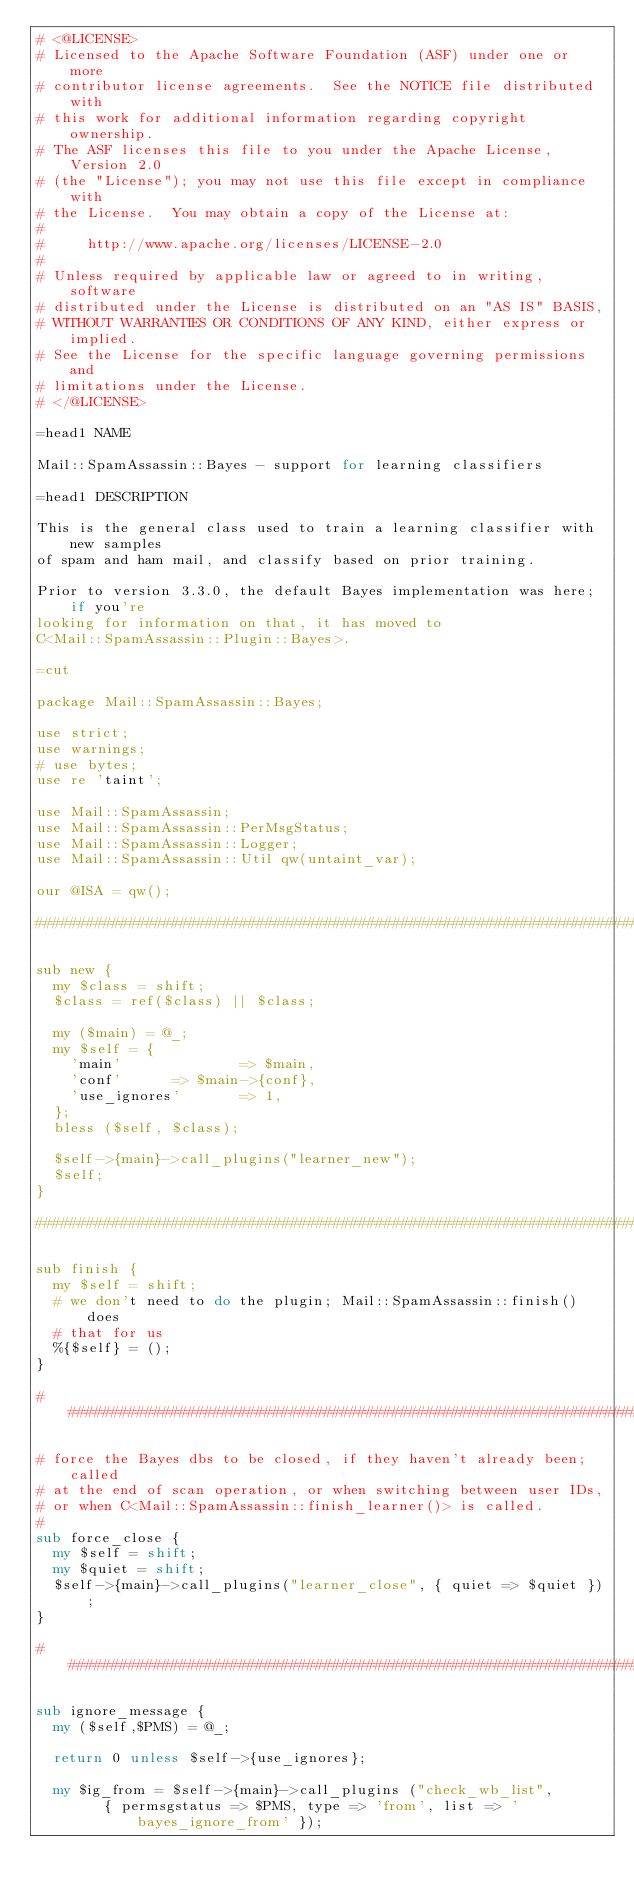<code> <loc_0><loc_0><loc_500><loc_500><_Perl_># <@LICENSE>
# Licensed to the Apache Software Foundation (ASF) under one or more
# contributor license agreements.  See the NOTICE file distributed with
# this work for additional information regarding copyright ownership.
# The ASF licenses this file to you under the Apache License, Version 2.0
# (the "License"); you may not use this file except in compliance with
# the License.  You may obtain a copy of the License at:
# 
#     http://www.apache.org/licenses/LICENSE-2.0
# 
# Unless required by applicable law or agreed to in writing, software
# distributed under the License is distributed on an "AS IS" BASIS,
# WITHOUT WARRANTIES OR CONDITIONS OF ANY KIND, either express or implied.
# See the License for the specific language governing permissions and
# limitations under the License.
# </@LICENSE>

=head1 NAME

Mail::SpamAssassin::Bayes - support for learning classifiers

=head1 DESCRIPTION

This is the general class used to train a learning classifier with new samples
of spam and ham mail, and classify based on prior training. 

Prior to version 3.3.0, the default Bayes implementation was here; if you're
looking for information on that, it has moved to
C<Mail::SpamAssassin::Plugin::Bayes>.

=cut

package Mail::SpamAssassin::Bayes;

use strict;
use warnings;
# use bytes;
use re 'taint';

use Mail::SpamAssassin;
use Mail::SpamAssassin::PerMsgStatus;
use Mail::SpamAssassin::Logger;
use Mail::SpamAssassin::Util qw(untaint_var);

our @ISA = qw();

###########################################################################

sub new {
  my $class = shift;
  $class = ref($class) || $class;

  my ($main) = @_;
  my $self = {
    'main'              => $main,
    'conf'		=> $main->{conf},
    'use_ignores'       => 1,
  };
  bless ($self, $class);

  $self->{main}->call_plugins("learner_new");
  $self;
}

###########################################################################

sub finish {
  my $self = shift;
  # we don't need to do the plugin; Mail::SpamAssassin::finish() does
  # that for us
  %{$self} = ();
}

###########################################################################

# force the Bayes dbs to be closed, if they haven't already been; called
# at the end of scan operation, or when switching between user IDs,
# or when C<Mail::SpamAssassin::finish_learner()> is called.
#
sub force_close {
  my $self = shift;
  my $quiet = shift;
  $self->{main}->call_plugins("learner_close", { quiet => $quiet });
}

###########################################################################

sub ignore_message {
  my ($self,$PMS) = @_;

  return 0 unless $self->{use_ignores};

  my $ig_from = $self->{main}->call_plugins ("check_wb_list",
        { permsgstatus => $PMS, type => 'from', list => 'bayes_ignore_from' });</code> 